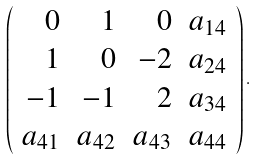<formula> <loc_0><loc_0><loc_500><loc_500>\left ( \begin{array} { r r r r } 0 & 1 & 0 & a _ { 1 4 } \\ 1 & 0 & - 2 & a _ { 2 4 } \\ - 1 & - 1 & 2 & a _ { 3 4 } \\ a _ { 4 1 } & a _ { 4 2 } & a _ { 4 3 } & a _ { 4 4 } \\ \end{array} \right ) .</formula> 